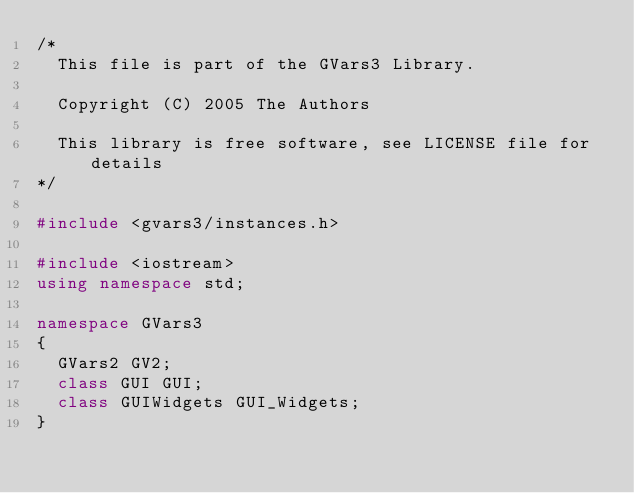<code> <loc_0><loc_0><loc_500><loc_500><_C++_>/*                       
	This file is part of the GVars3 Library.

	Copyright (C) 2005 The Authors

	This library is free software, see LICENSE file for details
*/

#include <gvars3/instances.h>

#include <iostream>
using namespace std;

namespace GVars3
{
	GVars2 GV2;
	class GUI GUI;
	class GUIWidgets GUI_Widgets;
}
</code> 